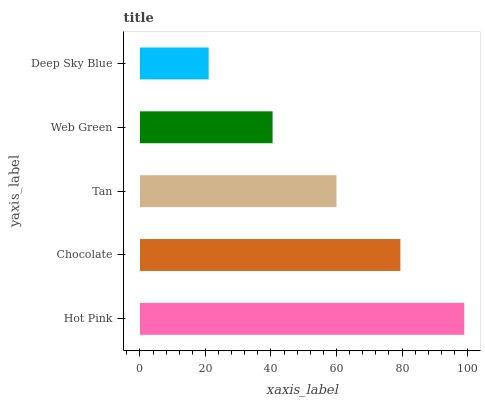Is Deep Sky Blue the minimum?
Answer yes or no. Yes. Is Hot Pink the maximum?
Answer yes or no. Yes. Is Chocolate the minimum?
Answer yes or no. No. Is Chocolate the maximum?
Answer yes or no. No. Is Hot Pink greater than Chocolate?
Answer yes or no. Yes. Is Chocolate less than Hot Pink?
Answer yes or no. Yes. Is Chocolate greater than Hot Pink?
Answer yes or no. No. Is Hot Pink less than Chocolate?
Answer yes or no. No. Is Tan the high median?
Answer yes or no. Yes. Is Tan the low median?
Answer yes or no. Yes. Is Web Green the high median?
Answer yes or no. No. Is Hot Pink the low median?
Answer yes or no. No. 